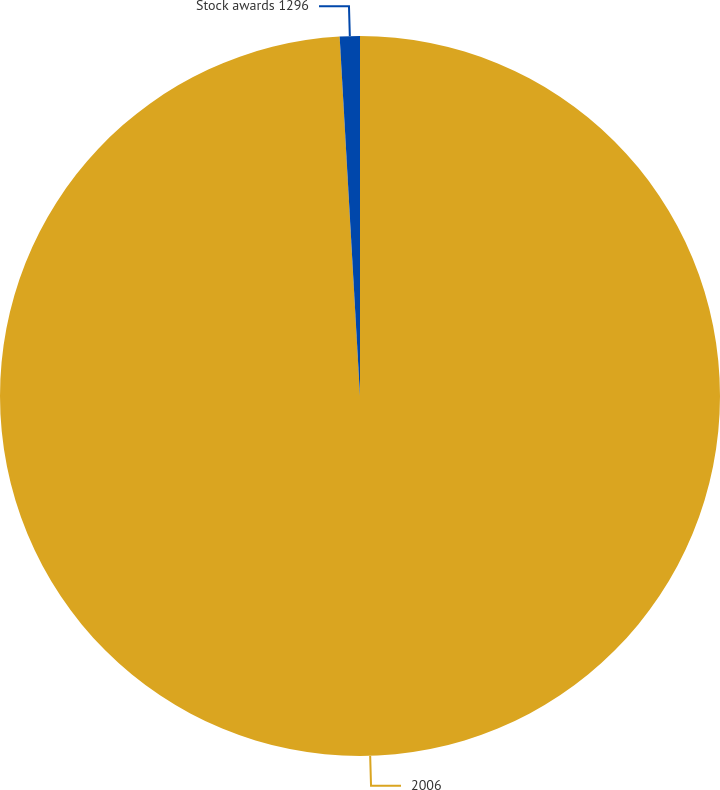Convert chart. <chart><loc_0><loc_0><loc_500><loc_500><pie_chart><fcel>2006<fcel>Stock awards 1296<nl><fcel>99.1%<fcel>0.9%<nl></chart> 